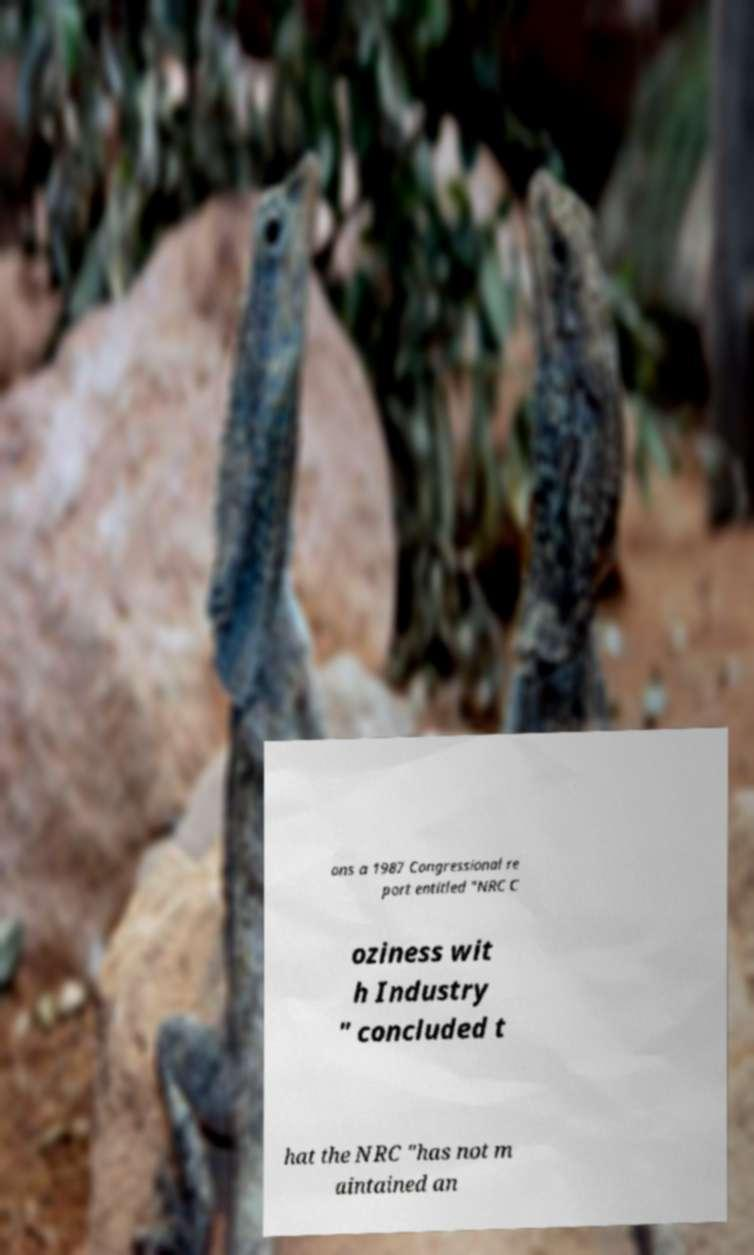There's text embedded in this image that I need extracted. Can you transcribe it verbatim? ons a 1987 Congressional re port entitled "NRC C oziness wit h Industry " concluded t hat the NRC "has not m aintained an 